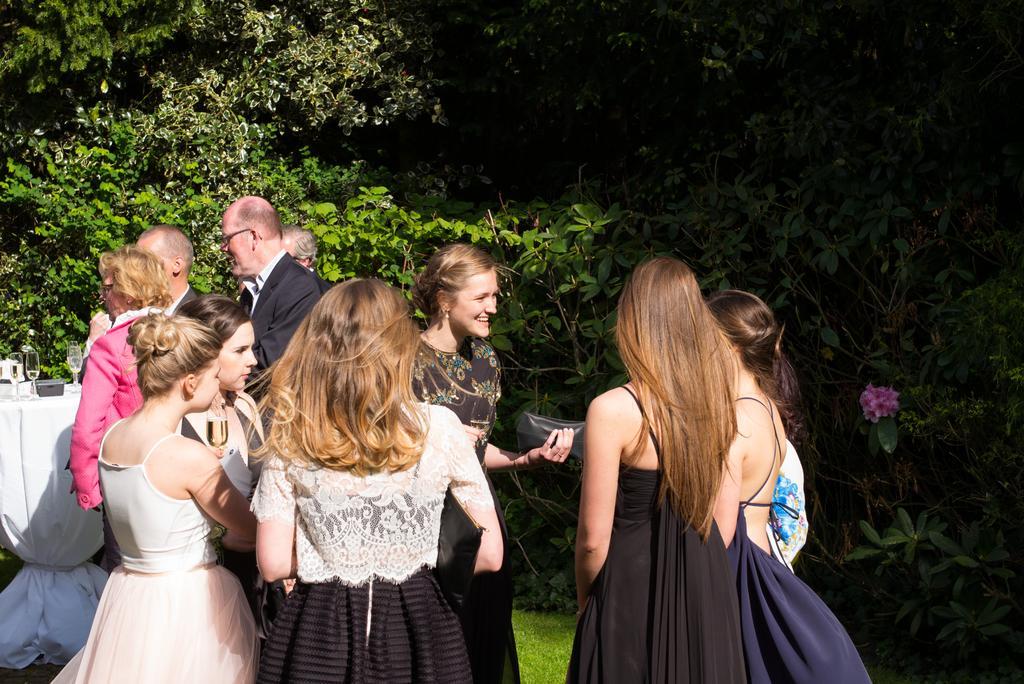Can you describe this image briefly? In this image, we can see a group of people wearing clothes. There are some plants in the middle of the image. There is a table on the left side of the image covered with a cloth. This table contains glasses. 